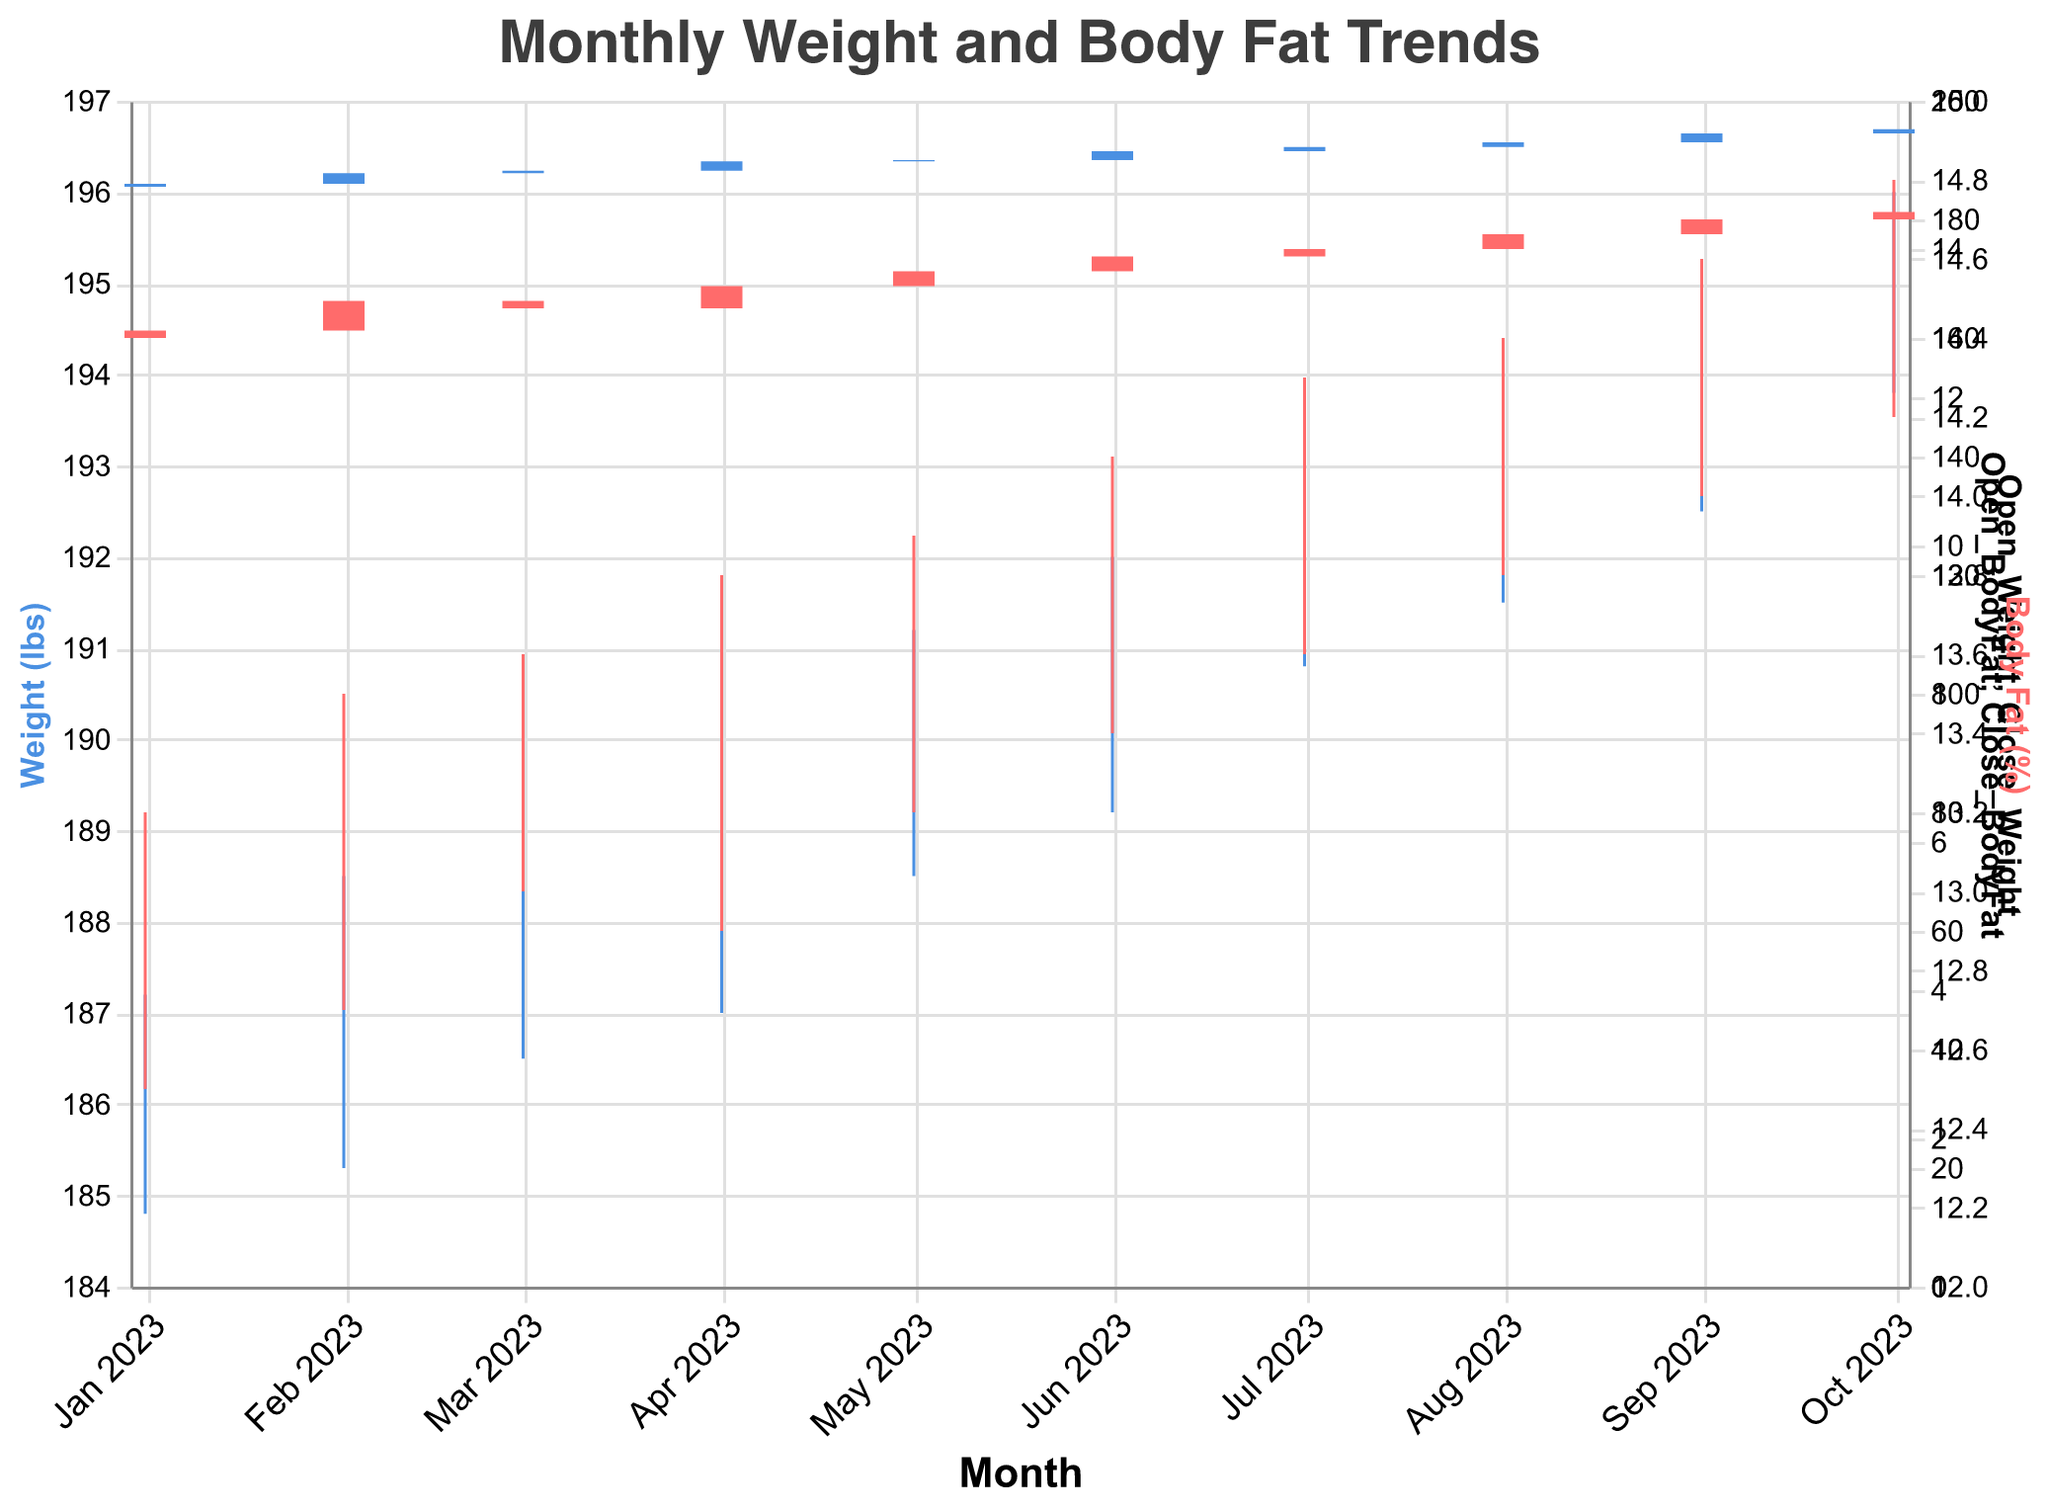What's the title of the figure? To find the title, look at the top of the chart. The title provides a summary of what the visual data represents.
Answer: Monthly Weight and Body Fat Trends What month had the highest weight? To find the month with the highest weight recorded, look for the highest point indicated by the "High_Weight" in the chart.
Answer: October 2023 Which month had the lowest body fat percentage recorded? To find the month with the lowest body fat percentage, identify the lowest value in the "Low_BodyFat" series.
Answer: January 2023 What's the weight range in April 2023? The weight range in a specific month can be found by subtracting the "Low_Weight" from the "High_Weight" for the month. For April 2023, the range is 190.5 - 187.0 = 3.5 lbs.
Answer: 3.5 lbs In which month did the weight increase the most from the opening to the closing? To determine when the weight increased the most, compare the difference between "Close_Weight" and "Open_Weight" for each month. The largest positive change is the answer. For example, in June 2023: 191.5 - 190.0 = 1.5 lbs.
Answer: June 2023 What's the average closing weight over the first six months? To find the average closing weight over the first six months, sum the "Close_Weight" for January to June and divide by 6: (186.0 + 187.8 + 188.2 + 189.8 + 190.0 + 191.5) / 6.
Answer: 188.9 lbs Did body fat percentage generally increase or decrease over the period displayed? To determine if the body fat percentage generally increased or decreased, look at the "Close_BodyFat" at the start (January 2023) and the end (October 2023). If the end value is higher, it increased.
Answer: Increased Which month showed the smallest fluctuation in body fat percentage? To find the smallest fluctuation, calculate the difference between "High_BodyFat" and "Low_BodyFat" for each month and identify the minimum value.
Answer: March 2023 Is there a correlation between weight and body fat percentage over the months? To identify a correlation, observe the trend of the weight and body fat percentage lines. If both increase or decrease together over time, there is a positive correlation.
Answer: Positive correlation 